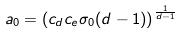<formula> <loc_0><loc_0><loc_500><loc_500>a _ { 0 } = \left ( c _ { d } c _ { e } \sigma _ { 0 } ( d - 1 ) \right ) ^ { \frac { 1 } { d - 1 } }</formula> 